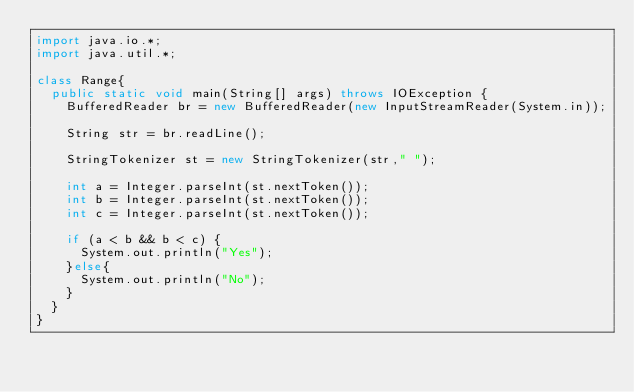<code> <loc_0><loc_0><loc_500><loc_500><_Java_>import java.io.*;
import java.util.*;

class Range{
	public static void main(String[] args) throws IOException {
		BufferedReader br = new BufferedReader(new InputStreamReader(System.in));
		
		String str = br.readLine();

		StringTokenizer st = new StringTokenizer(str," ");

		int a = Integer.parseInt(st.nextToken());
		int b = Integer.parseInt(st.nextToken());
		int c = Integer.parseInt(st.nextToken());

		if (a < b && b < c) {
			System.out.println("Yes");
		}else{
			System.out.println("No");
		}
	}
}</code> 